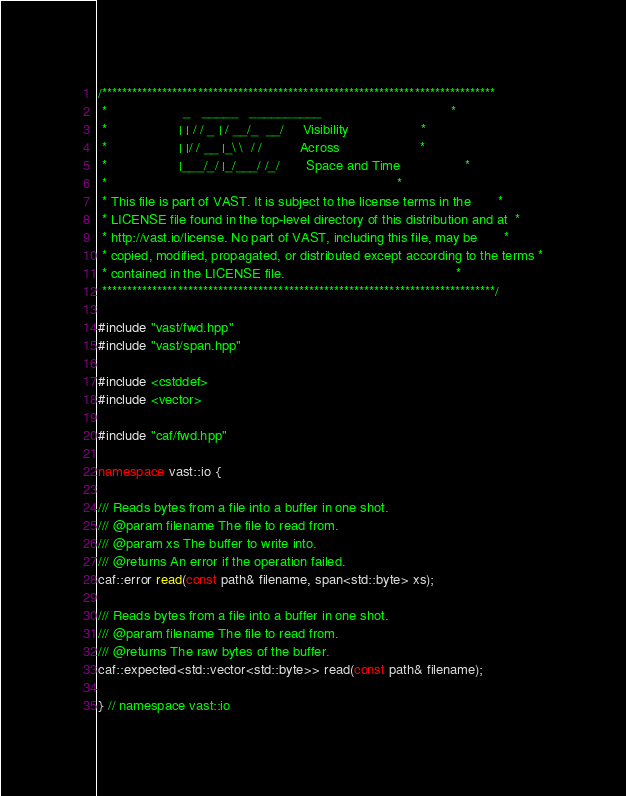Convert code to text. <code><loc_0><loc_0><loc_500><loc_500><_C++_>/******************************************************************************
 *                    _   _____   __________                                  *
 *                   | | / / _ | / __/_  __/     Visibility                   *
 *                   | |/ / __ |_\ \  / /          Across                     *
 *                   |___/_/ |_/___/ /_/       Space and Time                 *
 *                                                                            *
 * This file is part of VAST. It is subject to the license terms in the       *
 * LICENSE file found in the top-level directory of this distribution and at  *
 * http://vast.io/license. No part of VAST, including this file, may be       *
 * copied, modified, propagated, or distributed except according to the terms *
 * contained in the LICENSE file.                                             *
 ******************************************************************************/

#include "vast/fwd.hpp"
#include "vast/span.hpp"

#include <cstddef>
#include <vector>

#include "caf/fwd.hpp"

namespace vast::io {

/// Reads bytes from a file into a buffer in one shot.
/// @param filename The file to read from.
/// @param xs The buffer to write into.
/// @returns An error if the operation failed.
caf::error read(const path& filename, span<std::byte> xs);

/// Reads bytes from a file into a buffer in one shot.
/// @param filename The file to read from.
/// @returns The raw bytes of the buffer.
caf::expected<std::vector<std::byte>> read(const path& filename);

} // namespace vast::io
</code> 